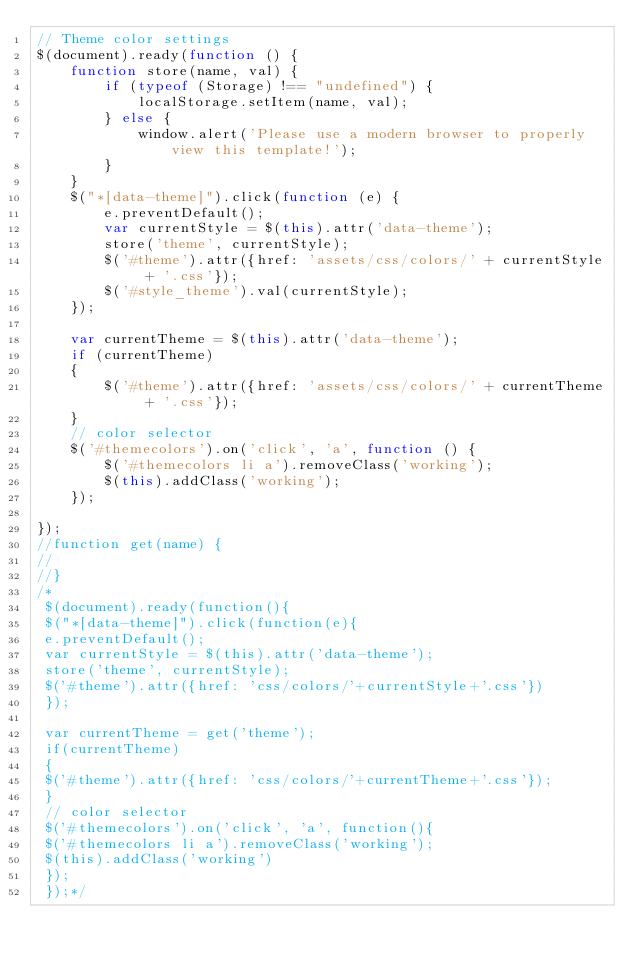Convert code to text. <code><loc_0><loc_0><loc_500><loc_500><_JavaScript_>// Theme color settings
$(document).ready(function () {
    function store(name, val) {
        if (typeof (Storage) !== "undefined") {
            localStorage.setItem(name, val);
        } else {
            window.alert('Please use a modern browser to properly view this template!');
        }
    }
    $("*[data-theme]").click(function (e) {
        e.preventDefault();
        var currentStyle = $(this).attr('data-theme');
        store('theme', currentStyle);
        $('#theme').attr({href: 'assets/css/colors/' + currentStyle + '.css'});
        $('#style_theme').val(currentStyle);
    });

    var currentTheme = $(this).attr('data-theme');
    if (currentTheme)
    {
        $('#theme').attr({href: 'assets/css/colors/' + currentTheme + '.css'});
    }
    // color selector
    $('#themecolors').on('click', 'a', function () {
        $('#themecolors li a').removeClass('working');
        $(this).addClass('working');
    });

});
//function get(name) {
//
//}
/*
 $(document).ready(function(){
 $("*[data-theme]").click(function(e){
 e.preventDefault();
 var currentStyle = $(this).attr('data-theme');
 store('theme', currentStyle);
 $('#theme').attr({href: 'css/colors/'+currentStyle+'.css'})
 });
 
 var currentTheme = get('theme');
 if(currentTheme)
 {
 $('#theme').attr({href: 'css/colors/'+currentTheme+'.css'});
 }
 // color selector
 $('#themecolors').on('click', 'a', function(){
 $('#themecolors li a').removeClass('working');
 $(this).addClass('working')
 });
 });*/
</code> 